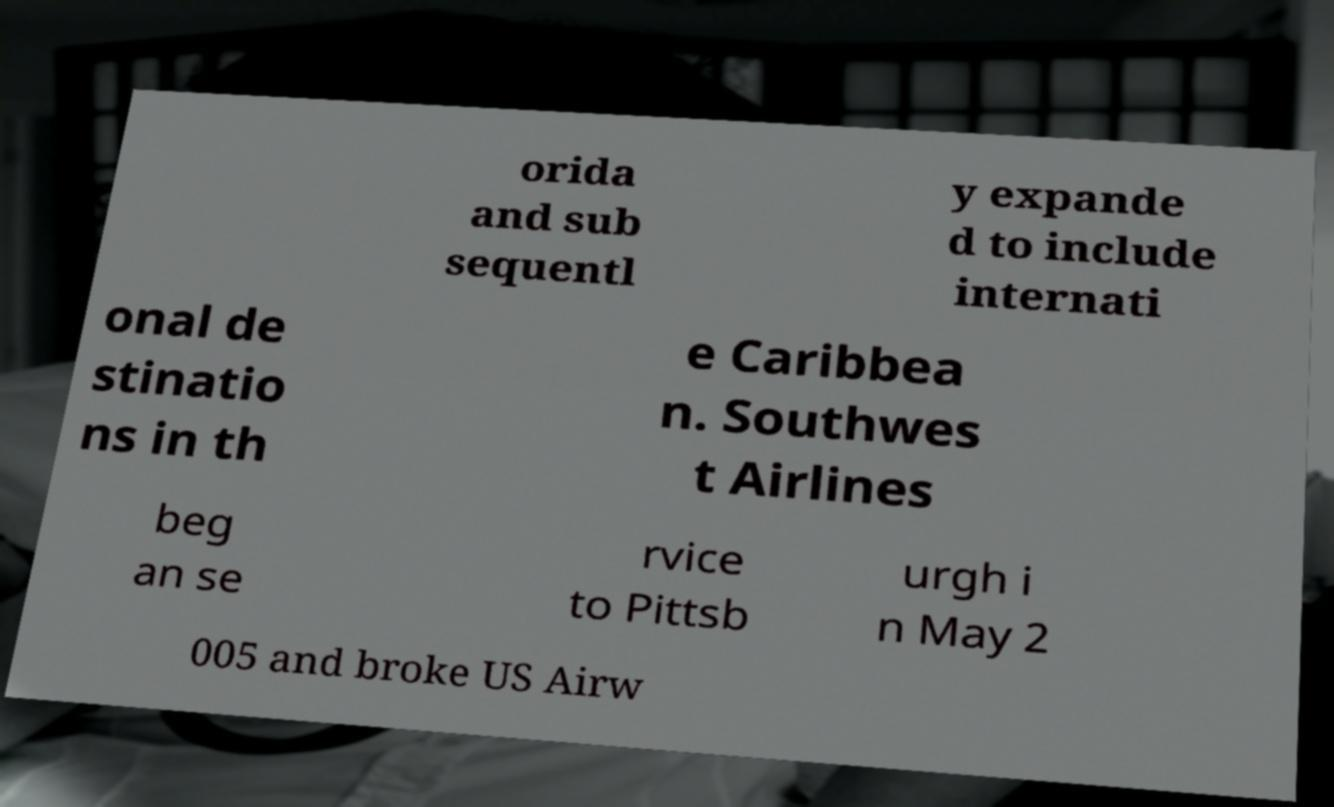For documentation purposes, I need the text within this image transcribed. Could you provide that? orida and sub sequentl y expande d to include internati onal de stinatio ns in th e Caribbea n. Southwes t Airlines beg an se rvice to Pittsb urgh i n May 2 005 and broke US Airw 